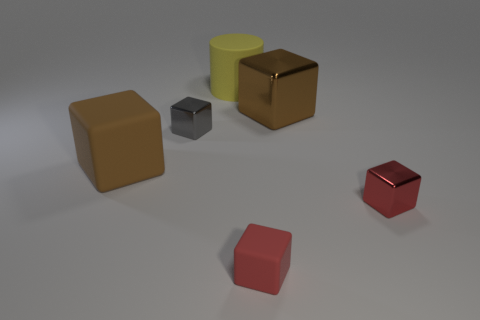Subtract all blue balls. How many brown cubes are left? 2 Subtract 2 cubes. How many cubes are left? 3 Subtract all large brown metallic cubes. How many cubes are left? 4 Subtract all gray blocks. How many blocks are left? 4 Add 4 tiny yellow shiny things. How many objects exist? 10 Subtract all purple cubes. Subtract all yellow spheres. How many cubes are left? 5 Subtract all cubes. How many objects are left? 1 Add 2 big brown rubber cubes. How many big brown rubber cubes are left? 3 Add 3 big cylinders. How many big cylinders exist? 4 Subtract 0 red cylinders. How many objects are left? 6 